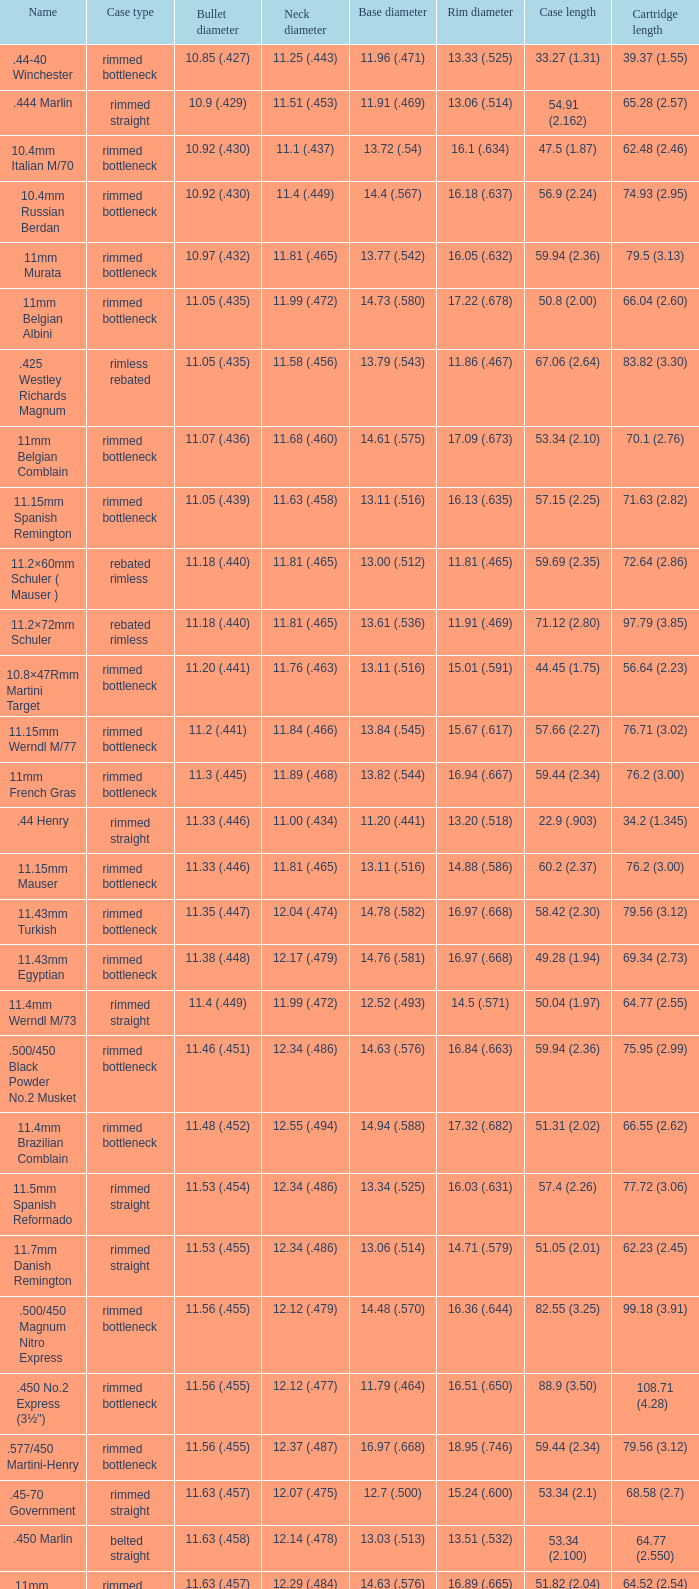In which case type can you find a 64.77mm (2.550-inch) cartridge length? Belted straight. 